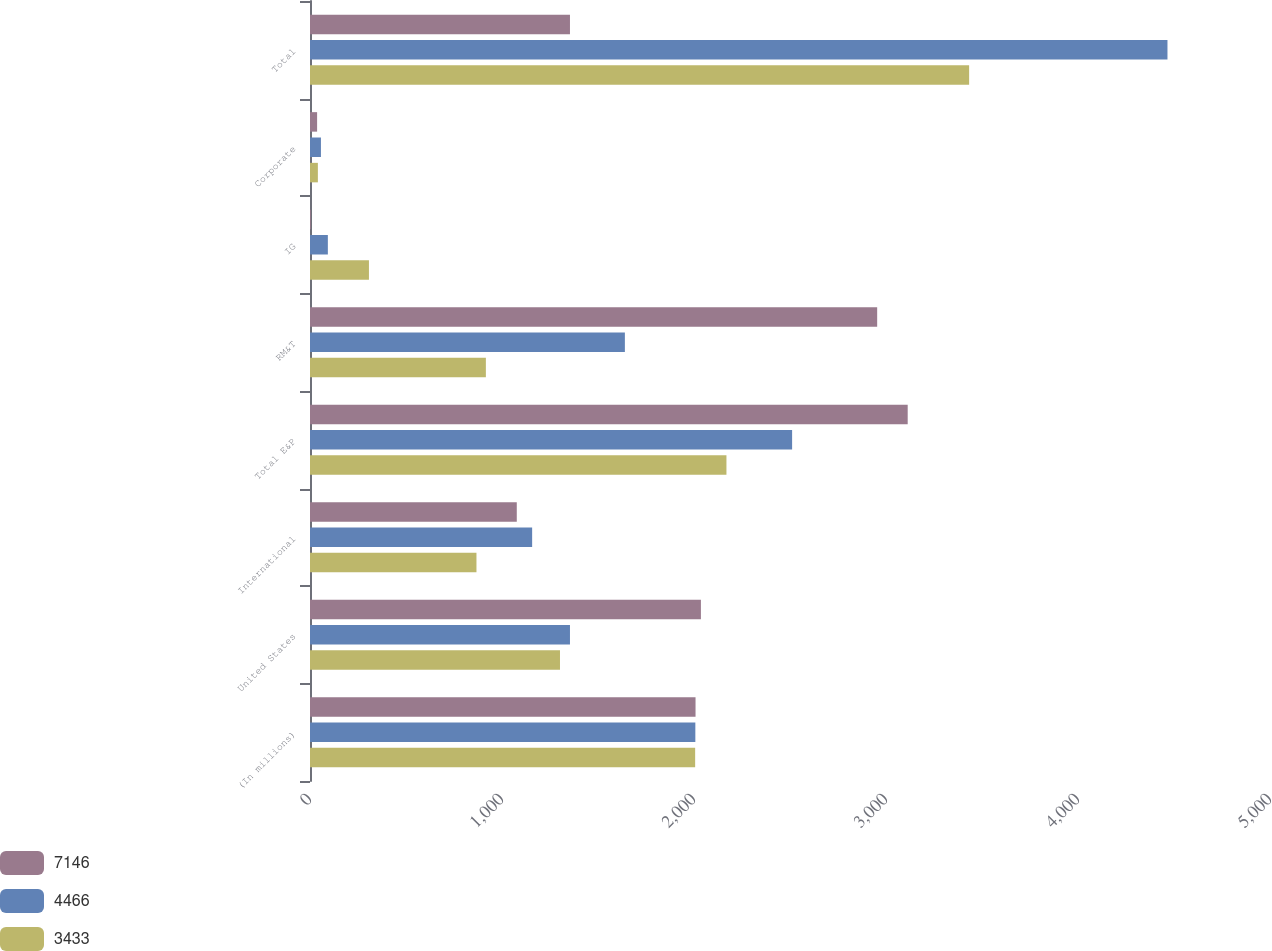Convert chart. <chart><loc_0><loc_0><loc_500><loc_500><stacked_bar_chart><ecel><fcel>(In millions)<fcel>United States<fcel>International<fcel>Total E&P<fcel>RM&T<fcel>IG<fcel>Corporate<fcel>Total<nl><fcel>7146<fcel>2008<fcel>2036<fcel>1077<fcel>3113<fcel>2954<fcel>4<fcel>37<fcel>1354<nl><fcel>4466<fcel>2007<fcel>1354<fcel>1157<fcel>2511<fcel>1640<fcel>93<fcel>57<fcel>4466<nl><fcel>3433<fcel>2006<fcel>1302<fcel>867<fcel>2169<fcel>916<fcel>307<fcel>41<fcel>3433<nl></chart> 